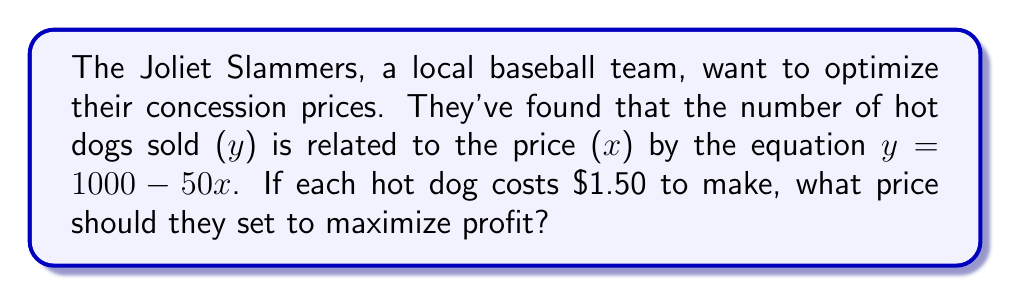Provide a solution to this math problem. Let's approach this step-by-step:

1) First, we need to create a profit function. Profit is revenue minus cost.

2) Revenue = Price × Quantity
   $R = xy = x(1000 - 50x) = 1000x - 50x^2$

3) Cost = Cost per unit × Quantity
   $C = 1.50(1000 - 50x) = 1500 - 75x$

4) Profit = Revenue - Cost
   $P = (1000x - 50x^2) - (1500 - 75x)$
   $P = 1000x - 50x^2 - 1500 + 75x$
   $P = -50x^2 + 1075x - 1500$

5) To find the maximum profit, we need to find where the derivative of P is zero:
   $\frac{dP}{dx} = -100x + 1075 = 0$

6) Solve for x:
   $-100x = -1075$
   $x = 10.75$

7) To confirm this is a maximum, we can check that the second derivative is negative:
   $\frac{d^2P}{dx^2} = -100$, which is indeed negative.

8) Therefore, the profit-maximizing price is $10.75 per hot dog.
Answer: $10.75 